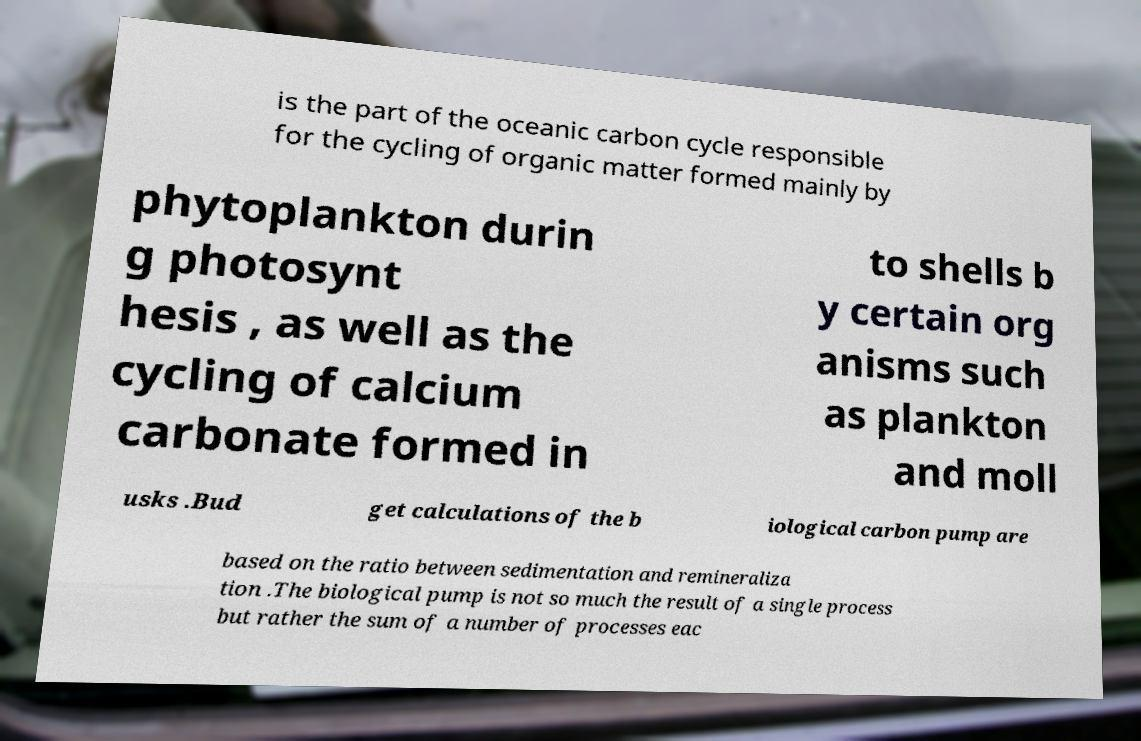I need the written content from this picture converted into text. Can you do that? is the part of the oceanic carbon cycle responsible for the cycling of organic matter formed mainly by phytoplankton durin g photosynt hesis , as well as the cycling of calcium carbonate formed in to shells b y certain org anisms such as plankton and moll usks .Bud get calculations of the b iological carbon pump are based on the ratio between sedimentation and remineraliza tion .The biological pump is not so much the result of a single process but rather the sum of a number of processes eac 